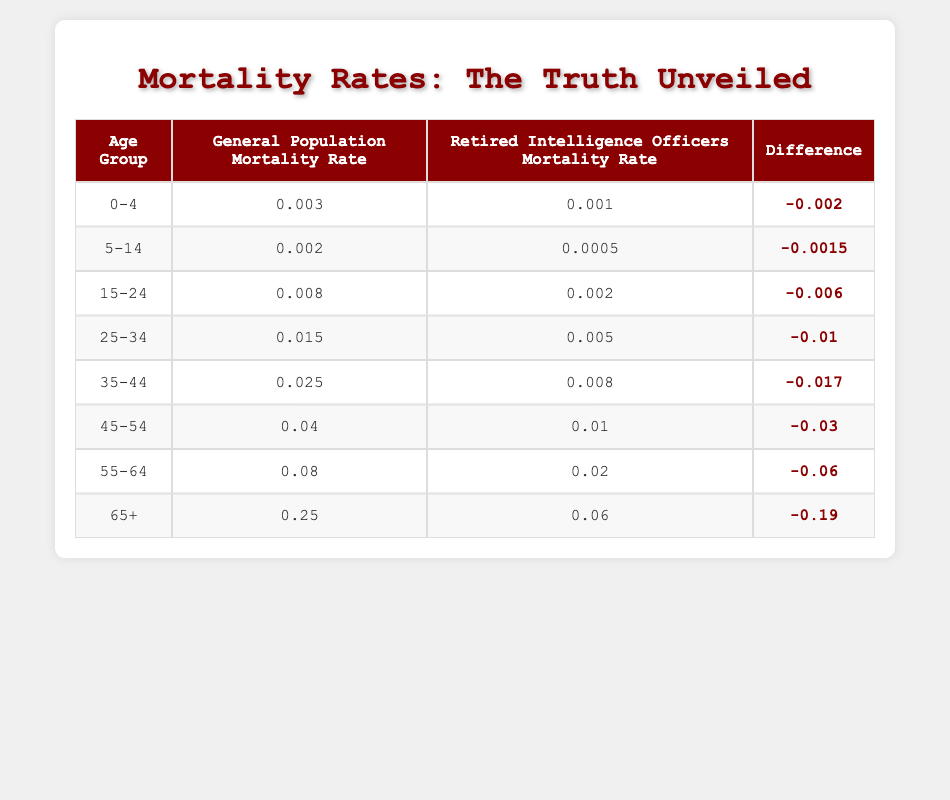What is the mortality rate for retired intelligence officers aged 25-34? According to the table, the mortality rate for retired intelligence officers in the age group 25-34 is listed directly as 0.005.
Answer: 0.005 What is the difference in mortality rates between the general population and retired intelligence officers for the age group 55-64? In the table, the mortality rate for the general population in the age group 55-64 is 0.08, and for retired intelligence officers, it is 0.02. The difference is calculated as 0.08 - 0.02 = 0.06.
Answer: 0.06 Is the mortality rate of retired intelligence officers aged 65 and older lower than that of the general population? The mortality rate for the general population aged 65 and older is 0.25, while that for retired intelligence officers is 0.06. Since 0.06 is less than 0.25, the statement is true.
Answer: Yes What is the average mortality rate of retired intelligence officers across all age groups? To find the average mortality rate, we sum all the mortality rates of retired intelligence officers: (0.001 + 0.0005 + 0.002 + 0.005 + 0.008 + 0.01 + 0.02 + 0.06) = 0.1065. Since there are 8 age groups, we divide this sum by 8: 0.1065 / 8 = 0.0133125, approximately.
Answer: 0.0133 Is the mortality rate for the age group 45-54 in the retired intelligence officer's data higher than that of the general population? The table shows that the mortality rate for retired intelligence officers in the age group 45-54 is 0.01, whereas for the general population it is 0.04. Since 0.01 is less than 0.04, the statement is false.
Answer: No What is the total number of deaths recorded for the general population in the age group 35-44? The table indicates that for the general population in the age group 35-44, the number of deaths is directly stated as 25000.
Answer: 25000 What is the combined mortality rate for retired intelligence officers aged 0-4 and 5-14? The mortality rate for retired intelligence officers aged 0-4 is 0.001 and for 5-14, it is 0.0005. Adding them together gives 0.001 + 0.0005 = 0.0015.
Answer: 0.0015 In which age group does the general population have the highest mortality rate? The table shows the mortality rates for the general population across age groups. The highest rate is 0.25, which corresponds to the age group 65+.
Answer: 65+ 